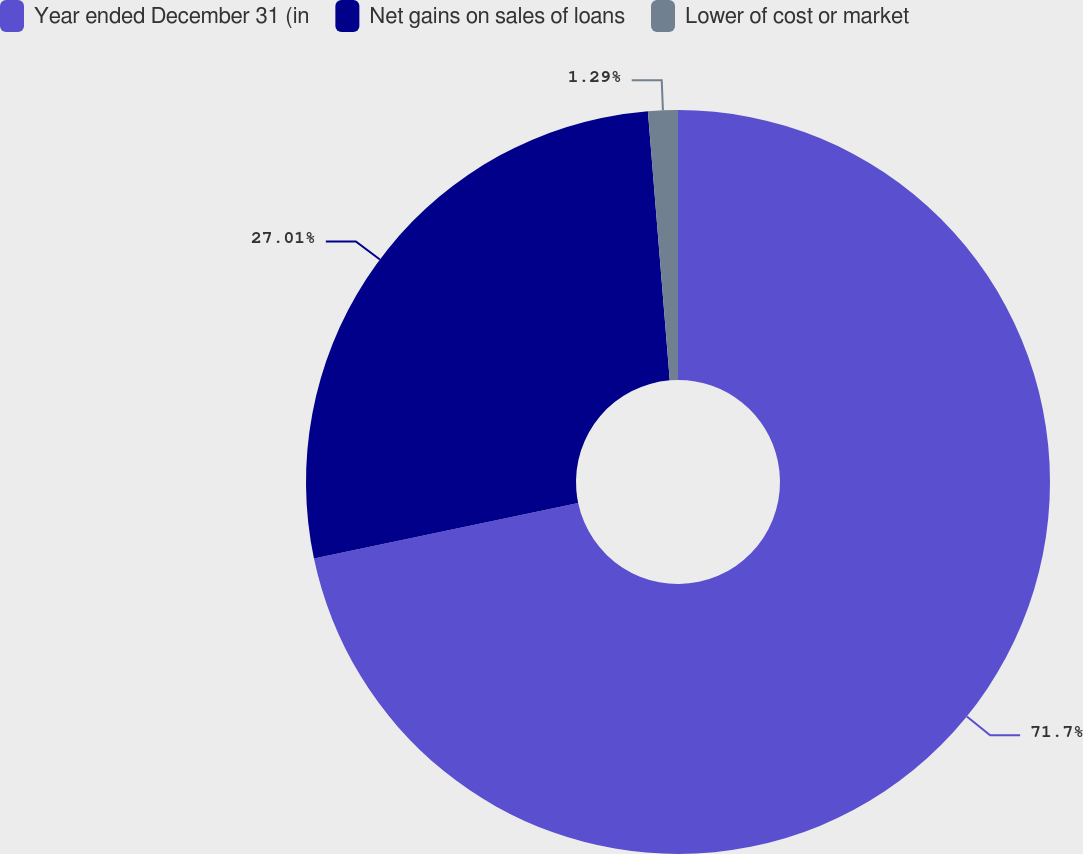Convert chart to OTSL. <chart><loc_0><loc_0><loc_500><loc_500><pie_chart><fcel>Year ended December 31 (in<fcel>Net gains on sales of loans<fcel>Lower of cost or market<nl><fcel>71.7%<fcel>27.01%<fcel>1.29%<nl></chart> 